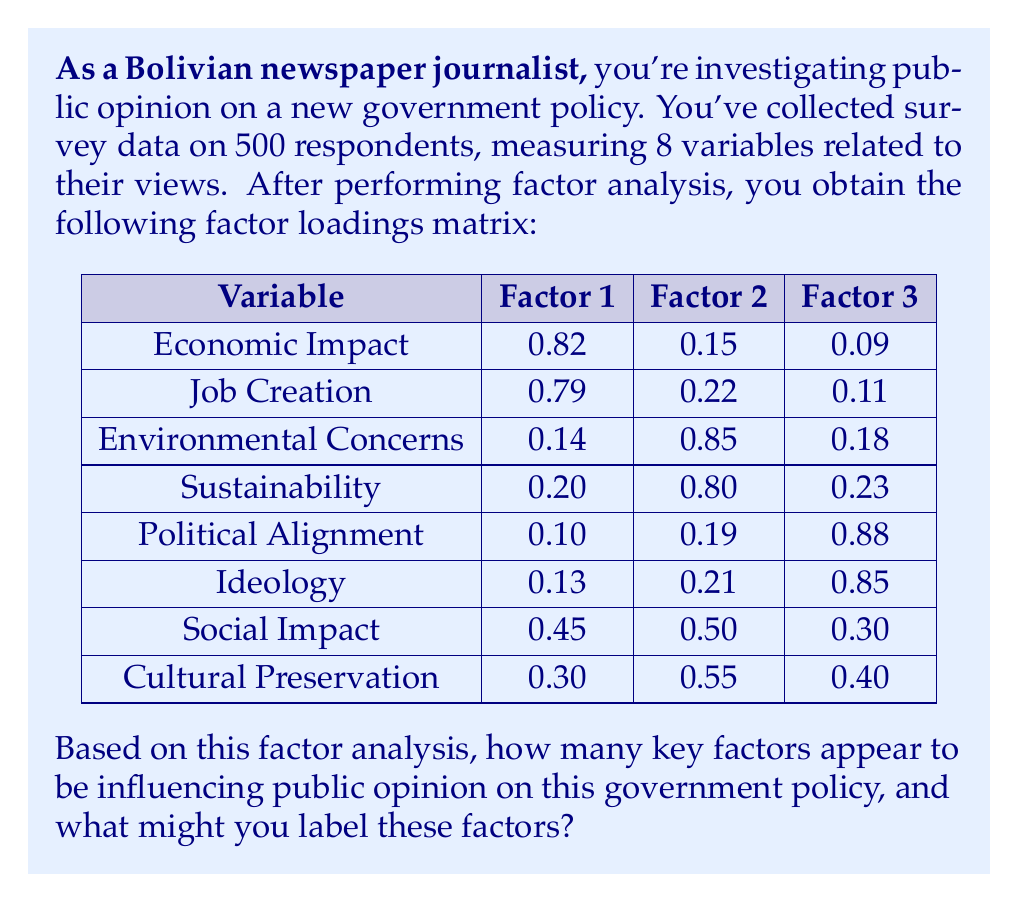Solve this math problem. To determine the number of key factors and their labels, we'll follow these steps:

1. Identify significant factor loadings:
   - Generally, factor loadings > 0.7 are considered significant.
   - Look for the highest loading for each variable across factors.

2. Analyze the pattern of loadings:
   Factor 1:
   - Economic Impact (0.82)
   - Job Creation (0.79)
   
   Factor 2:
   - Environmental Concerns (0.85)
   - Sustainability (0.80)
   
   Factor 3:
   - Political Alignment (0.88)
   - Ideology (0.85)

3. Count the number of factors with significant loadings:
   We can see that there are 3 distinct factors with significant loadings.

4. Label the factors based on the variables they represent:
   Factor 1: Economic Considerations (Economic Impact, Job Creation)
   Factor 2: Environmental Considerations (Environmental Concerns, Sustainability)
   Factor 3: Political Considerations (Political Alignment, Ideology)

5. Note on cross-loading variables:
   - Social Impact and Cultural Preservation don't load strongly on any single factor.
   - They have moderate loadings across multiple factors, indicating they might be influenced by a combination of the three main factors.

Therefore, we can conclude that there are 3 key factors influencing public opinion on this government policy: Economic Considerations, Environmental Considerations, and Political Considerations.
Answer: 3 factors: Economic, Environmental, and Political Considerations 